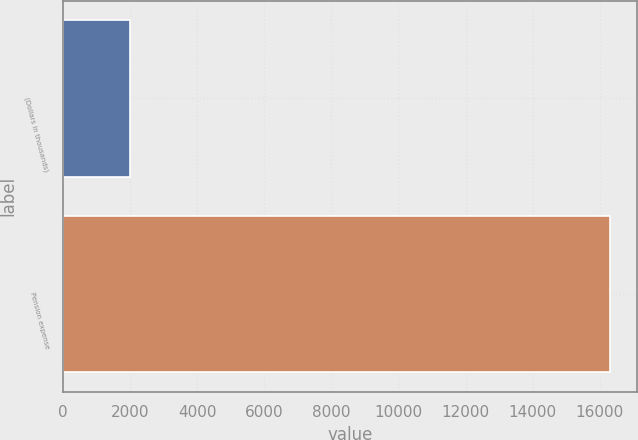Convert chart. <chart><loc_0><loc_0><loc_500><loc_500><bar_chart><fcel>(Dollars in thousands)<fcel>Pension expense<nl><fcel>2017<fcel>16299<nl></chart> 